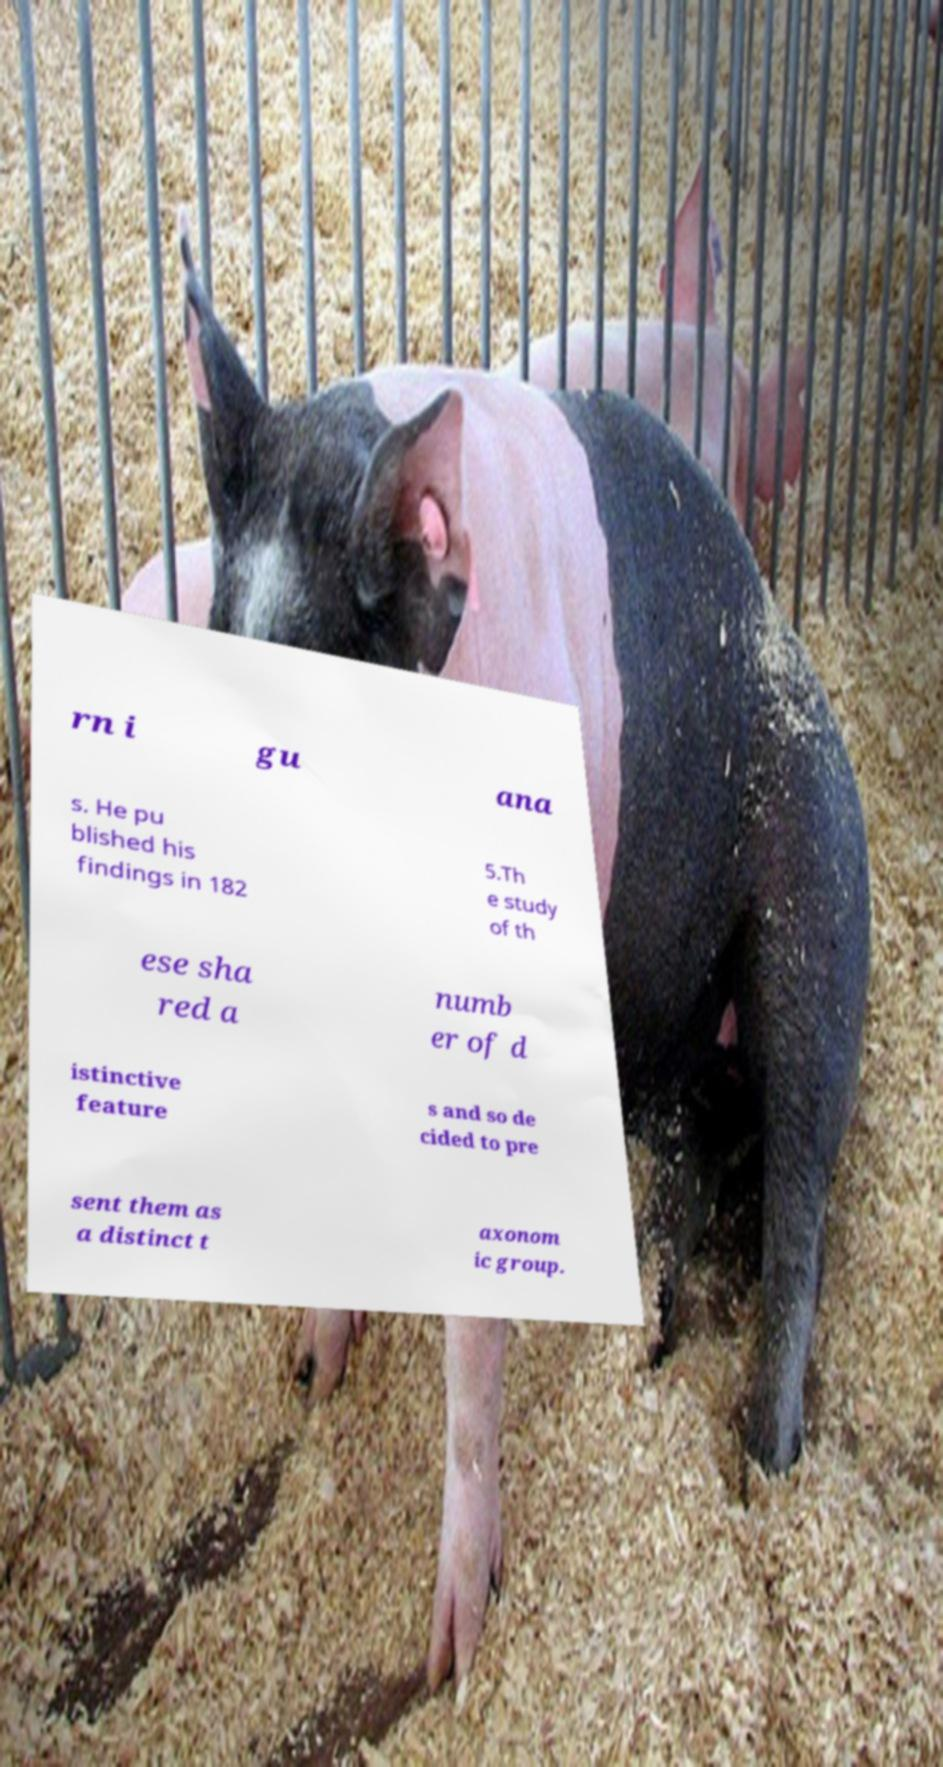Could you extract and type out the text from this image? rn i gu ana s. He pu blished his findings in 182 5.Th e study of th ese sha red a numb er of d istinctive feature s and so de cided to pre sent them as a distinct t axonom ic group. 